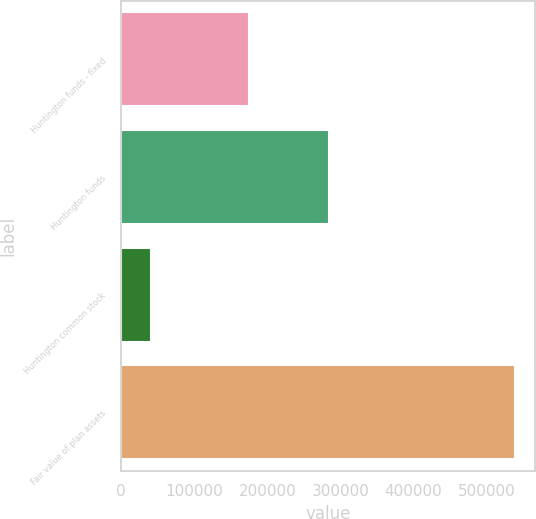Convert chart to OTSL. <chart><loc_0><loc_0><loc_500><loc_500><bar_chart><fcel>Huntington funds - fixed<fcel>Huntington funds<fcel>Huntington common stock<fcel>Fair value of plan assets<nl><fcel>174615<fcel>283963<fcel>40424<fcel>538970<nl></chart> 